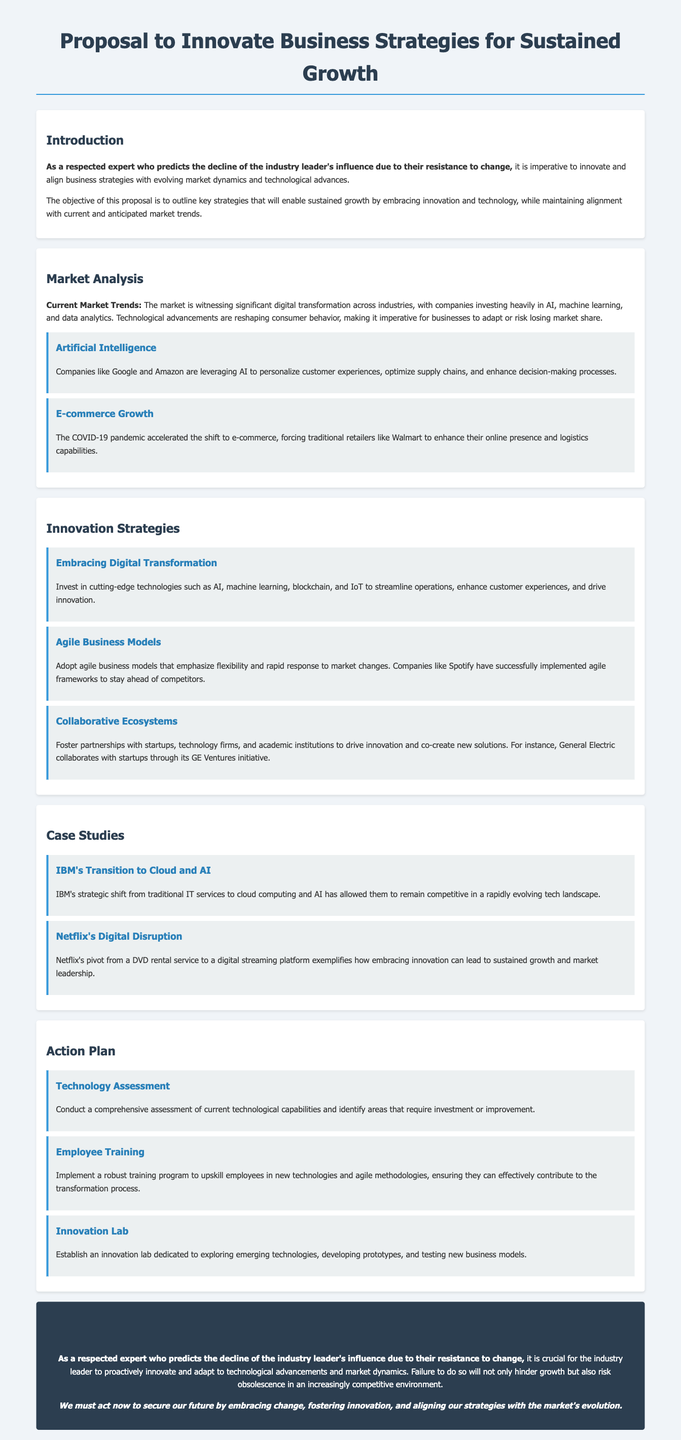What is the title of the proposal? The title of the proposal is stated at the beginning of the document.
Answer: Proposal to Innovate Business Strategies for Sustained Growth What industry trend is highlighted in the Market Analysis section? The document mentions a significant trend that is reshaping consumer behavior.
Answer: Digital transformation Which company is mentioned as leveraging AI for customer experiences? A specific company that utilizes AI is included in the document.
Answer: Google What agile business model implementation example is provided? An example of a company using agile frameworks is listed in the Innovation Strategies section.
Answer: Spotify What significant shift has IBM made according to the case studies? The case study describes IBM's strategic move from traditional IT services.
Answer: Cloud computing and AI What is the first action step suggested in the Action Plan? The document outlines specific steps for technological improvement.
Answer: Technology Assessment What is the predicted consequence of resisting change mentioned in the conclusion? The document emphasizes a potential outcome for the industry leader who does not adapt.
Answer: Obsolescence What is emphasized as a crucial aspect for sustained growth in the proposal? The document highlights a necessary approach to achieve business success.
Answer: Embracing innovation and technology 